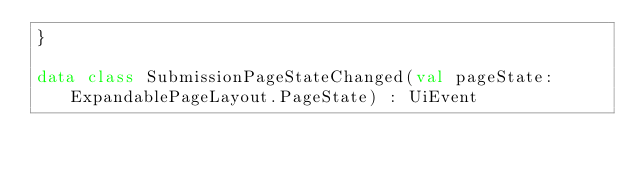<code> <loc_0><loc_0><loc_500><loc_500><_Kotlin_>}

data class SubmissionPageStateChanged(val pageState: ExpandablePageLayout.PageState) : UiEvent
</code> 